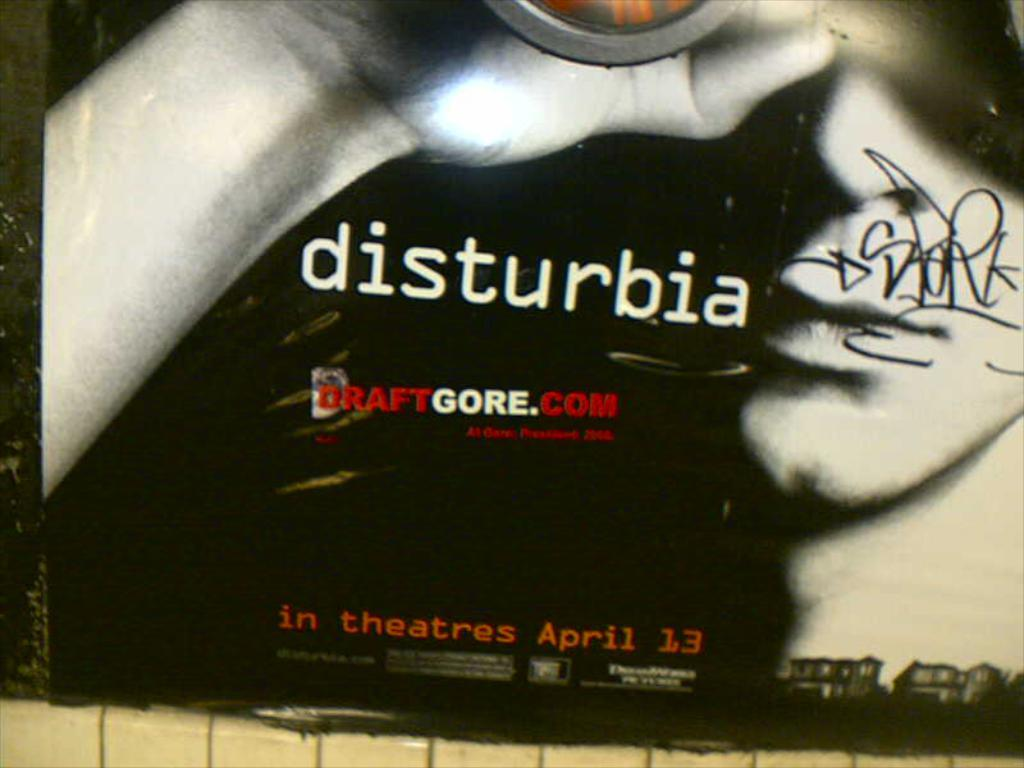What type of image is being displayed? The image is an advertisement. What can be seen on the wall in the image? There is a poster on the wall in the image. What type of beef is being advertised in the image? There is no beef present in the image; it is an advertisement with a poster on the wall. How much does the bird weigh in the image? There is no bird present in the image, so its weight cannot be determined. 